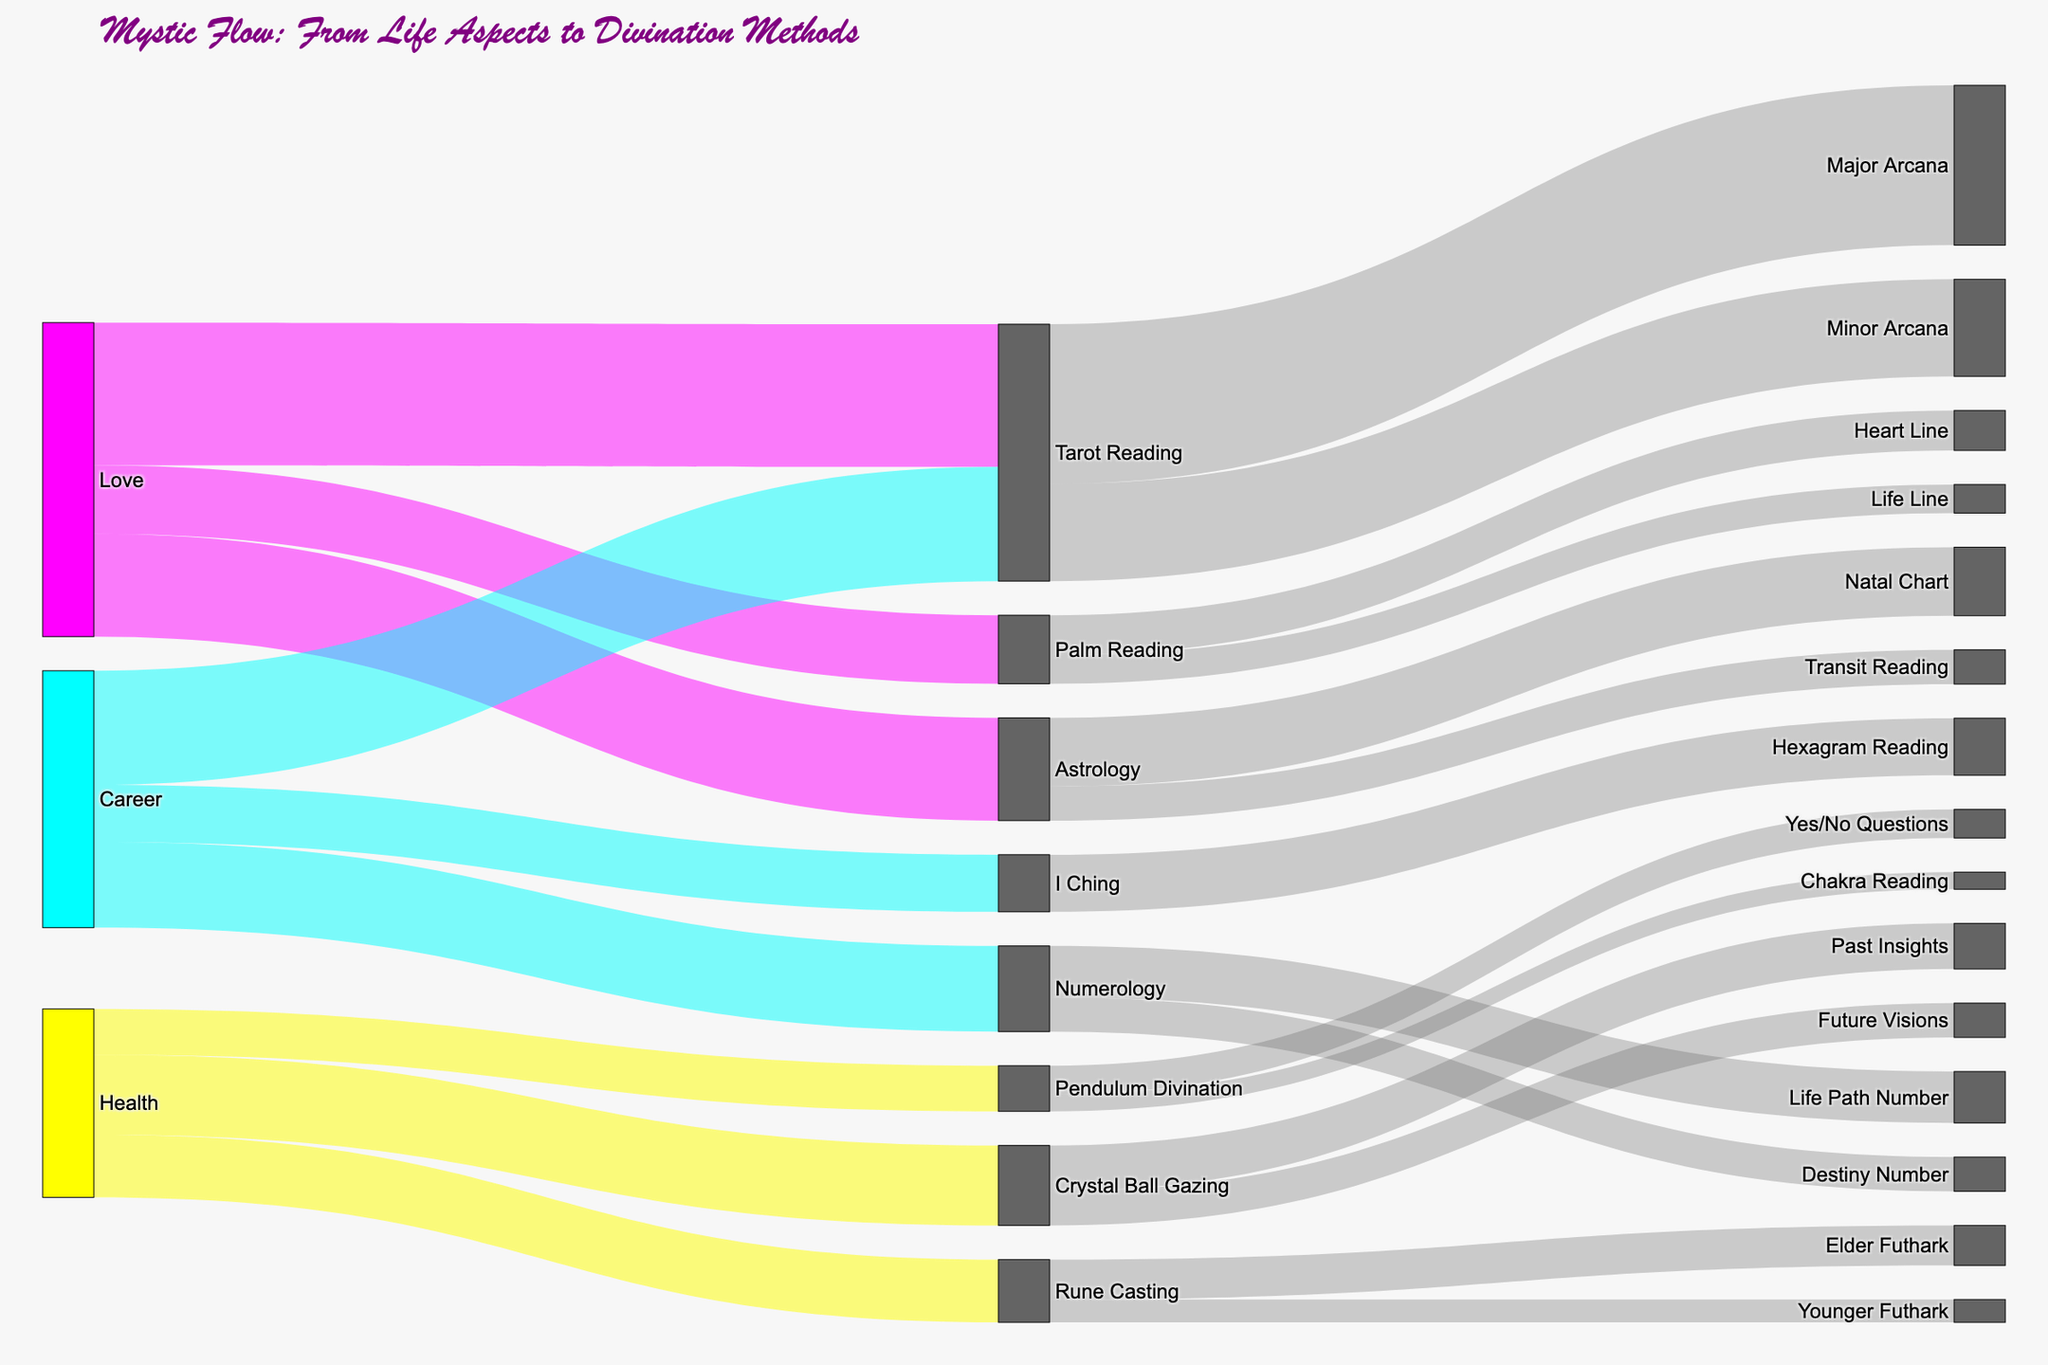What life aspect has the highest number of inquiries for Tarot Reading? From the diagram, follow the flow lines originating from each life aspect (Love, Career, Health) and see which has the largest value leading to Tarot Reading. The love aspect has a flow totaling 250 inquiries directed to Tarot Reading.
Answer: Love How does the number of inquiries for Astrology in the Love category compare to those for Numerology in the Career category? The diagram shows flows of 180 inquiries from Love to Astrology and 150 inquiries from Career to Numerology. Comparing these numbers, Astrology in the Love category has 30 more inquiries than Numerology in the Career category.
Answer: Astrology in Love has more inquiries What is the total number of inquiries in the Health category? To find the total inquiries in the Health category, sum up the values of flows leading from Health to their respective divination methods: Crystal Ball Gazing (140), Rune Casting (110), and Pendulum Divination (80). Thus, 140 + 110 + 80 = 330 inquiries.
Answer: 330 Which specific divination method within Astrology receives the most inquiries, and how many? Follow the flow from Astrology to its related divination methods. The diagram shows that the Natal Chart has 120 inquiries and Transit Reading has 60 inquiries. Therefore, the Natal Chart receives the most inquiries within Astrology.
Answer: Natal Chart, 120 Is there a divination method whose inquiries are equally split between two sub-methods? Check if there is an equal split among methods and sub-methods in the diagram. For Tarot Reading, Major Arcana contains 280 inquiries and Minor Arcana contains 170 inquiries, which is not equal. For Astrology, the split between Natal Chart (120) and Transit Reading (60) is also not equal. All other divisions show unequal splits. However, for Crystal Ball Gazing, the split between Past Insights (80) and Future Visions (60) also is not equal. Thus, no divination method has an equal split.
Answer: No What divination methods are used for inquiries about Career? Trace the flows originating from Career to the methods they're directed to. Career inquiries are directed to Tarot Reading, Numerology, and I Ching.
Answer: Tarot Reading, Numerology, I Ching Which sub-category of Pendulum Divination receives fewer inquiries, and how many? Within Pendulum Divination, follow the flow to its sub-categories. Yes/No Questions receive 50 inquiries, and Chakra Reading receives 30 inquiries. Thus, Chakra Reading receives fewer inquiries.
Answer: Chakra Reading, 30 How many inquiries for Love are directed towards Palm Reading? Find the flow value from the Love category leading to Palm Reading. The diagram indicates that 120 inquiries from the Love aspect are directed to Palm Reading.
Answer: 120 What is the most popular divination method for the Health aspect and what is the total number of inquiries for it? Trace the flows originating from Health and see which method has the highest value. Crystal Ball Gazing has the highest number of inquiries with 140.
Answer: Crystal Ball Gazing, 140 